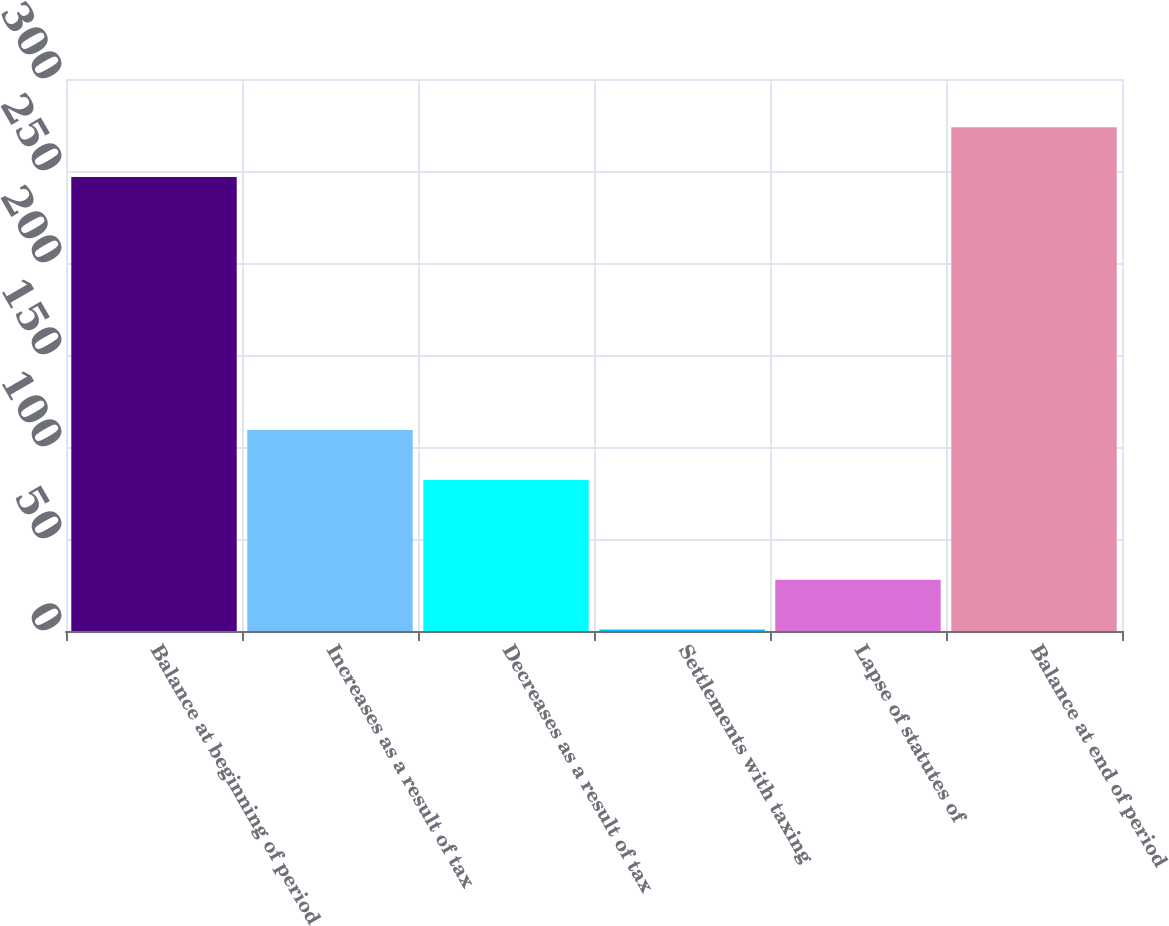Convert chart. <chart><loc_0><loc_0><loc_500><loc_500><bar_chart><fcel>Balance at beginning of period<fcel>Increases as a result of tax<fcel>Decreases as a result of tax<fcel>Settlements with taxing<fcel>Lapse of statutes of<fcel>Balance at end of period<nl><fcel>246.7<fcel>109.24<fcel>82.13<fcel>0.8<fcel>27.91<fcel>273.81<nl></chart> 